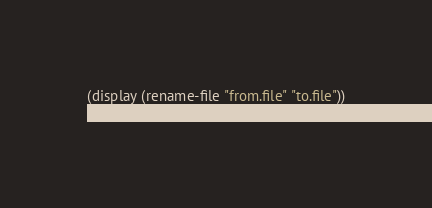<code> <loc_0><loc_0><loc_500><loc_500><_Scheme_>(display (rename-file "from.file" "to.file"))
(newline)
</code> 